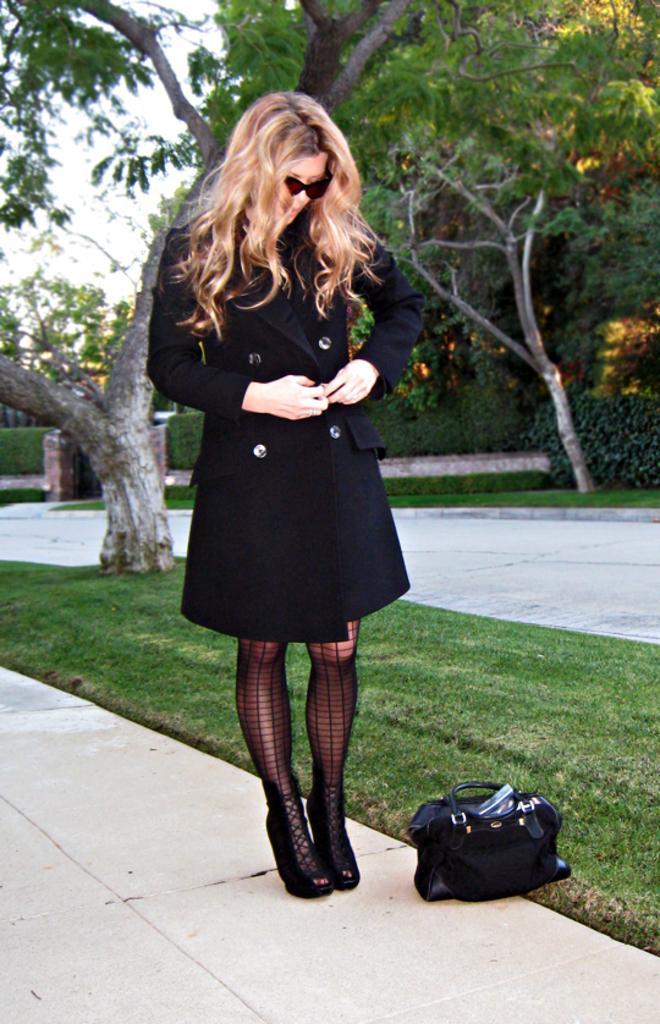How would you summarize this image in a sentence or two? I can see in this image a woman is wearing a black dress standing on the road and wearing glasses. I can also see there is bag on the ground and a couple of trees in the background. 